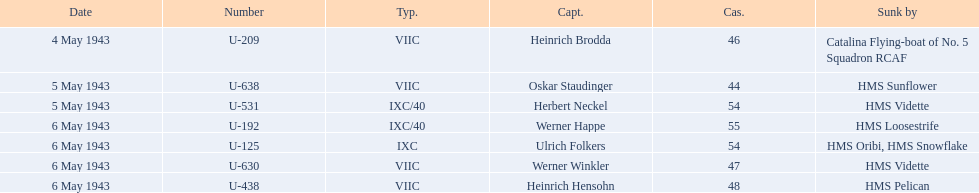Who were the captains in the ons 5 convoy? Heinrich Brodda, Oskar Staudinger, Herbert Neckel, Werner Happe, Ulrich Folkers, Werner Winkler, Heinrich Hensohn. Which ones lost their u-boat on may 5? Oskar Staudinger, Herbert Neckel. Of those, which one is not oskar staudinger? Herbert Neckel. 